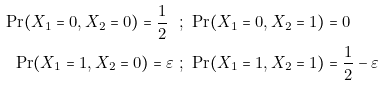Convert formula to latex. <formula><loc_0><loc_0><loc_500><loc_500>\Pr ( X _ { 1 } = 0 , X _ { 2 } = 0 ) = \frac { 1 } { 2 } \ & ; \ \Pr ( X _ { 1 } = 0 , X _ { 2 } = 1 ) = 0 \\ \Pr ( X _ { 1 } = 1 , X _ { 2 } = 0 ) = \varepsilon \ & ; \ \Pr ( X _ { 1 } = 1 , X _ { 2 } = 1 ) = \frac { 1 } { 2 } - \varepsilon</formula> 